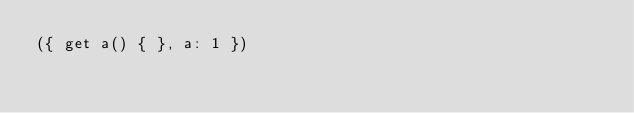<code> <loc_0><loc_0><loc_500><loc_500><_JavaScript_>({ get a() { }, a: 1 })</code> 